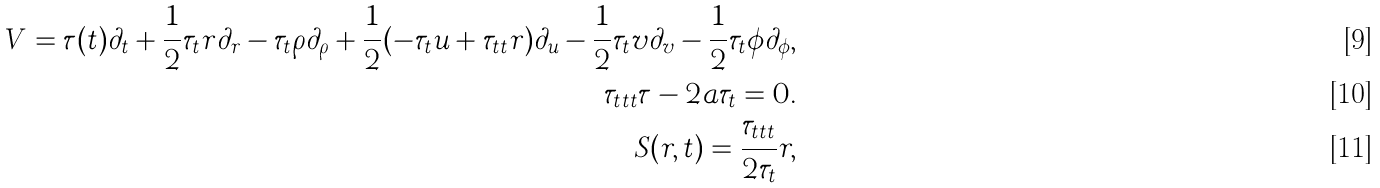<formula> <loc_0><loc_0><loc_500><loc_500>V = \tau ( t ) \partial _ { t } + \frac { 1 } { 2 } \tau _ { t } r \partial _ { r } - \tau _ { t } \rho \partial _ { \rho } + \frac { 1 } { 2 } ( - \tau _ { t } u + \tau _ { t t } r ) \partial _ { u } - \frac { 1 } { 2 } \tau _ { t } v \partial _ { v } - \frac { 1 } { 2 } \tau _ { t } \phi \partial _ { \phi } , \\ \tau _ { t t t } \tau - 2 a \tau _ { t } = 0 . \\ S ( r , t ) = \frac { \tau _ { t t t } } { 2 \tau _ { t } } r ,</formula> 